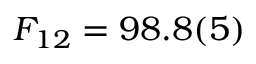<formula> <loc_0><loc_0><loc_500><loc_500>F _ { 1 2 } = 9 8 . 8 ( 5 ) \</formula> 